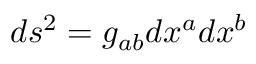<formula> <loc_0><loc_0><loc_500><loc_500>d s ^ { 2 } = g _ { a b } d x ^ { a } d x ^ { b }</formula> 